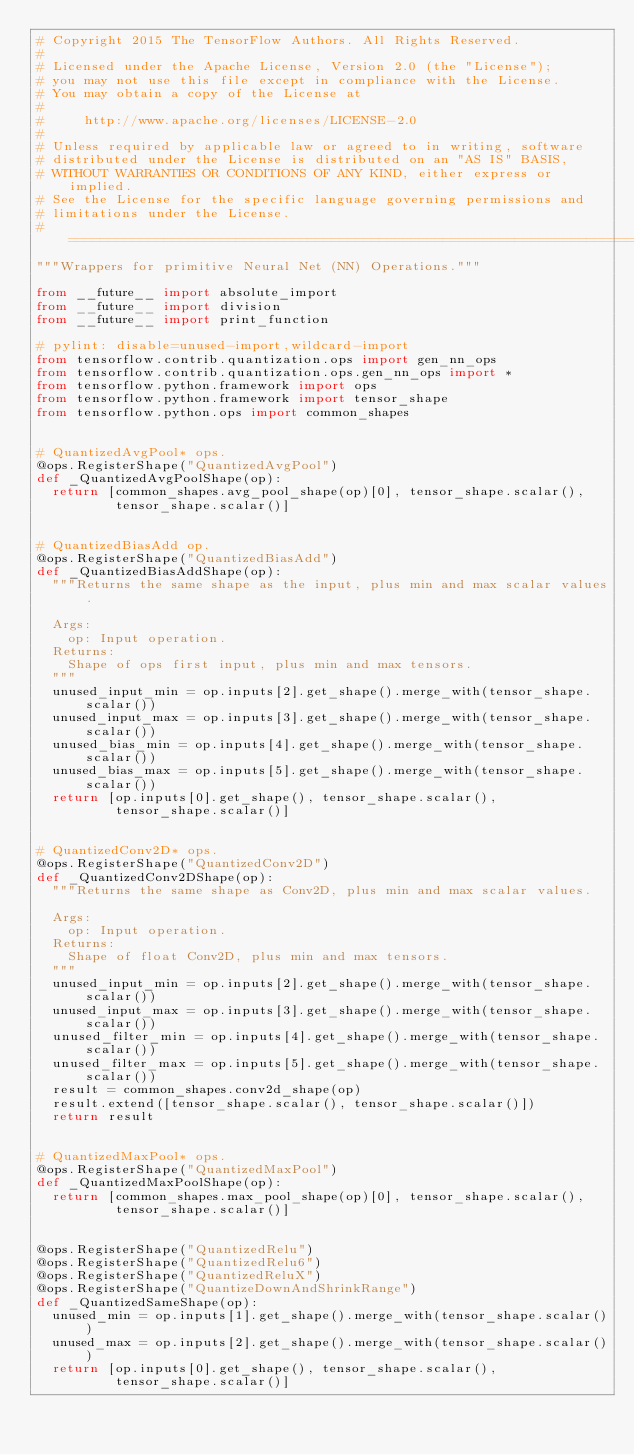<code> <loc_0><loc_0><loc_500><loc_500><_Python_># Copyright 2015 The TensorFlow Authors. All Rights Reserved.
#
# Licensed under the Apache License, Version 2.0 (the "License");
# you may not use this file except in compliance with the License.
# You may obtain a copy of the License at
#
#     http://www.apache.org/licenses/LICENSE-2.0
#
# Unless required by applicable law or agreed to in writing, software
# distributed under the License is distributed on an "AS IS" BASIS,
# WITHOUT WARRANTIES OR CONDITIONS OF ANY KIND, either express or implied.
# See the License for the specific language governing permissions and
# limitations under the License.
# ==============================================================================
"""Wrappers for primitive Neural Net (NN) Operations."""

from __future__ import absolute_import
from __future__ import division
from __future__ import print_function

# pylint: disable=unused-import,wildcard-import
from tensorflow.contrib.quantization.ops import gen_nn_ops
from tensorflow.contrib.quantization.ops.gen_nn_ops import *
from tensorflow.python.framework import ops
from tensorflow.python.framework import tensor_shape
from tensorflow.python.ops import common_shapes


# QuantizedAvgPool* ops.
@ops.RegisterShape("QuantizedAvgPool")
def _QuantizedAvgPoolShape(op):
  return [common_shapes.avg_pool_shape(op)[0], tensor_shape.scalar(),
          tensor_shape.scalar()]


# QuantizedBiasAdd op.
@ops.RegisterShape("QuantizedBiasAdd")
def _QuantizedBiasAddShape(op):
  """Returns the same shape as the input, plus min and max scalar values.

  Args:
    op: Input operation.
  Returns:
    Shape of ops first input, plus min and max tensors.
  """
  unused_input_min = op.inputs[2].get_shape().merge_with(tensor_shape.scalar())
  unused_input_max = op.inputs[3].get_shape().merge_with(tensor_shape.scalar())
  unused_bias_min = op.inputs[4].get_shape().merge_with(tensor_shape.scalar())
  unused_bias_max = op.inputs[5].get_shape().merge_with(tensor_shape.scalar())
  return [op.inputs[0].get_shape(), tensor_shape.scalar(),
          tensor_shape.scalar()]


# QuantizedConv2D* ops.
@ops.RegisterShape("QuantizedConv2D")
def _QuantizedConv2DShape(op):
  """Returns the same shape as Conv2D, plus min and max scalar values.

  Args:
    op: Input operation.
  Returns:
    Shape of float Conv2D, plus min and max tensors.
  """
  unused_input_min = op.inputs[2].get_shape().merge_with(tensor_shape.scalar())
  unused_input_max = op.inputs[3].get_shape().merge_with(tensor_shape.scalar())
  unused_filter_min = op.inputs[4].get_shape().merge_with(tensor_shape.scalar())
  unused_filter_max = op.inputs[5].get_shape().merge_with(tensor_shape.scalar())
  result = common_shapes.conv2d_shape(op)
  result.extend([tensor_shape.scalar(), tensor_shape.scalar()])
  return result


# QuantizedMaxPool* ops.
@ops.RegisterShape("QuantizedMaxPool")
def _QuantizedMaxPoolShape(op):
  return [common_shapes.max_pool_shape(op)[0], tensor_shape.scalar(),
          tensor_shape.scalar()]


@ops.RegisterShape("QuantizedRelu")
@ops.RegisterShape("QuantizedRelu6")
@ops.RegisterShape("QuantizedReluX")
@ops.RegisterShape("QuantizeDownAndShrinkRange")
def _QuantizedSameShape(op):
  unused_min = op.inputs[1].get_shape().merge_with(tensor_shape.scalar())
  unused_max = op.inputs[2].get_shape().merge_with(tensor_shape.scalar())
  return [op.inputs[0].get_shape(), tensor_shape.scalar(),
          tensor_shape.scalar()]
</code> 